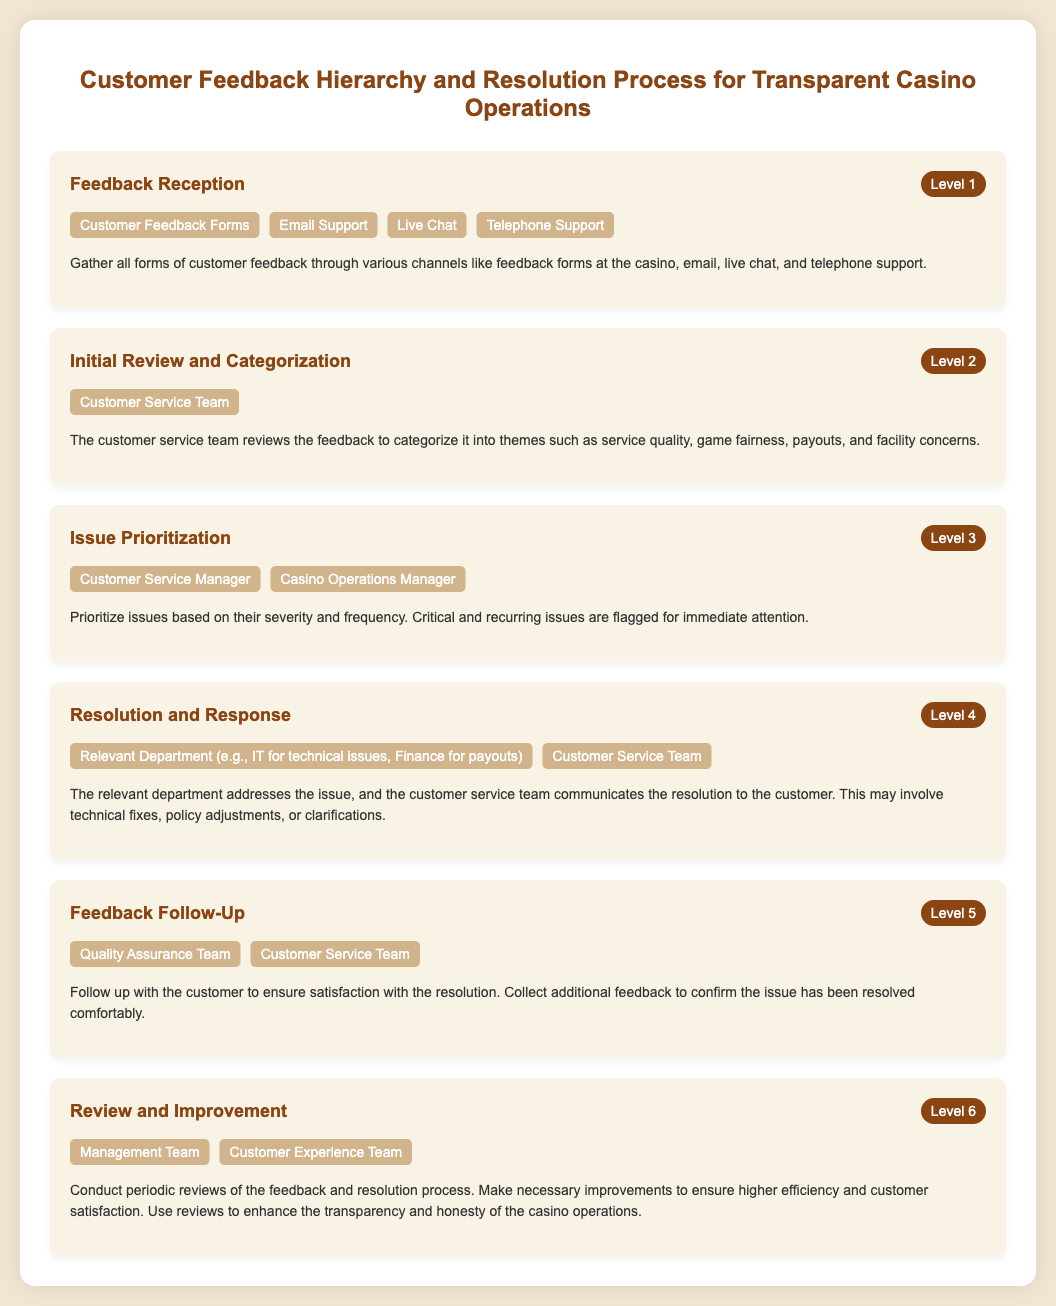What is the first level of the hierarchy? The first level of the hierarchy is titled "Feedback Reception," which is where all forms of customer feedback are gathered.
Answer: Feedback Reception Who handles the initial review of feedback? The initial review and categorization of feedback is conducted by the Customer Service Team.
Answer: Customer Service Team How many levels are in the feedback hierarchy? The document outlines a total of six levels in the feedback hierarchy and resolution process.
Answer: 6 Which entities are involved in the resolution of issues? The relevant department for the issue and the Customer Service Team are both involved in the resolution and response process.
Answer: Relevant Department, Customer Service Team What is the purpose of the Feedback Follow-Up level? The Feedback Follow-Up level aims to check customer satisfaction with the resolution and collect additional feedback.
Answer: Ensure satisfaction Who is responsible for periodic reviews of the feedback process? The Management Team and Customer Experience Team are responsible for conducting periodic reviews of the feedback and resolution process.
Answer: Management Team, Customer Experience Team 